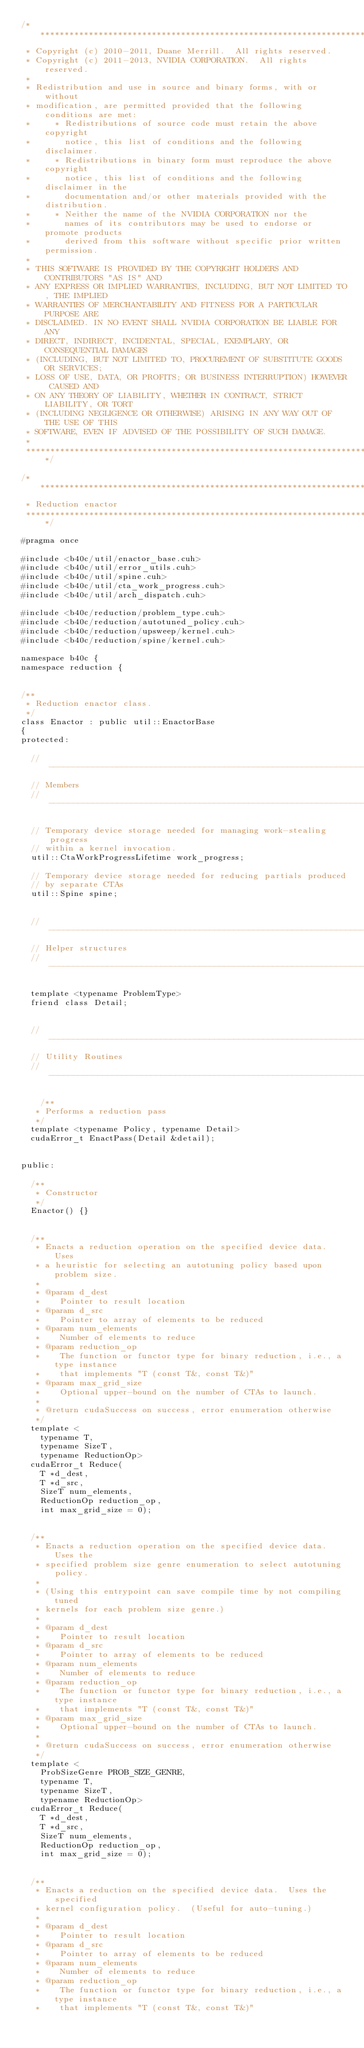Convert code to text. <code><loc_0><loc_0><loc_500><loc_500><_Cuda_>/******************************************************************************
 * Copyright (c) 2010-2011, Duane Merrill.  All rights reserved.
 * Copyright (c) 2011-2013, NVIDIA CORPORATION.  All rights reserved.
 * 
 * Redistribution and use in source and binary forms, with or without
 * modification, are permitted provided that the following conditions are met:
 *     * Redistributions of source code must retain the above copyright
 *       notice, this list of conditions and the following disclaimer.
 *     * Redistributions in binary form must reproduce the above copyright
 *       notice, this list of conditions and the following disclaimer in the
 *       documentation and/or other materials provided with the distribution.
 *     * Neither the name of the NVIDIA CORPORATION nor the
 *       names of its contributors may be used to endorse or promote products
 *       derived from this software without specific prior written permission.
 * 
 * THIS SOFTWARE IS PROVIDED BY THE COPYRIGHT HOLDERS AND CONTRIBUTORS "AS IS" AND
 * ANY EXPRESS OR IMPLIED WARRANTIES, INCLUDING, BUT NOT LIMITED TO, THE IMPLIED
 * WARRANTIES OF MERCHANTABILITY AND FITNESS FOR A PARTICULAR PURPOSE ARE
 * DISCLAIMED. IN NO EVENT SHALL NVIDIA CORPORATION BE LIABLE FOR ANY
 * DIRECT, INDIRECT, INCIDENTAL, SPECIAL, EXEMPLARY, OR CONSEQUENTIAL DAMAGES
 * (INCLUDING, BUT NOT LIMITED TO, PROCUREMENT OF SUBSTITUTE GOODS OR SERVICES;
 * LOSS OF USE, DATA, OR PROFITS; OR BUSINESS INTERRUPTION) HOWEVER CAUSED AND
 * ON ANY THEORY OF LIABILITY, WHETHER IN CONTRACT, STRICT LIABILITY, OR TORT
 * (INCLUDING NEGLIGENCE OR OTHERWISE) ARISING IN ANY WAY OUT OF THE USE OF THIS
 * SOFTWARE, EVEN IF ADVISED OF THE POSSIBILITY OF SUCH DAMAGE.
 *
 ******************************************************************************/

/******************************************************************************
 * Reduction enactor
 ******************************************************************************/

#pragma once

#include <b40c/util/enactor_base.cuh>
#include <b40c/util/error_utils.cuh>
#include <b40c/util/spine.cuh>
#include <b40c/util/cta_work_progress.cuh>
#include <b40c/util/arch_dispatch.cuh>

#include <b40c/reduction/problem_type.cuh>
#include <b40c/reduction/autotuned_policy.cuh>
#include <b40c/reduction/upsweep/kernel.cuh>
#include <b40c/reduction/spine/kernel.cuh>

namespace b40c {
namespace reduction {


/**
 * Reduction enactor class.
 */
class Enactor : public util::EnactorBase
{
protected:

	//---------------------------------------------------------------------
	// Members
	//---------------------------------------------------------------------

	// Temporary device storage needed for managing work-stealing progress
	// within a kernel invocation.
	util::CtaWorkProgressLifetime work_progress;

	// Temporary device storage needed for reducing partials produced
	// by separate CTAs
	util::Spine spine;


	//-----------------------------------------------------------------------------
	// Helper structures
	//-----------------------------------------------------------------------------

	template <typename ProblemType>
	friend class Detail;


	//-----------------------------------------------------------------------------
	// Utility Routines
	//-----------------------------------------------------------------------------

    /**
	 * Performs a reduction pass
	 */
	template <typename Policy, typename Detail>
	cudaError_t EnactPass(Detail &detail);


public:

	/**
	 * Constructor
	 */
	Enactor() {}


	/**
	 * Enacts a reduction operation on the specified device data.  Uses
	 * a heuristic for selecting an autotuning policy based upon problem size.
	 *
	 * @param d_dest
	 * 		Pointer to result location
	 * @param d_src
	 * 		Pointer to array of elements to be reduced
	 * @param num_elements
	 * 		Number of elements to reduce
	 * @param reduction_op
	 * 		The function or functor type for binary reduction, i.e., a type instance
	 * 		that implements "T (const T&, const T&)"
	 * @param max_grid_size
	 * 		Optional upper-bound on the number of CTAs to launch.
	 *
	 * @return cudaSuccess on success, error enumeration otherwise
	 */
	template <
		typename T,
		typename SizeT,
		typename ReductionOp>
	cudaError_t Reduce(
		T *d_dest,
		T *d_src,
		SizeT num_elements,
		ReductionOp reduction_op,
		int max_grid_size = 0);


	/**
	 * Enacts a reduction operation on the specified device data.  Uses the
	 * specified problem size genre enumeration to select autotuning policy.
	 *
	 * (Using this entrypoint can save compile time by not compiling tuned
	 * kernels for each problem size genre.)
	 *
	 * @param d_dest
	 * 		Pointer to result location
	 * @param d_src
	 * 		Pointer to array of elements to be reduced
	 * @param num_elements
	 * 		Number of elements to reduce
	 * @param reduction_op
	 * 		The function or functor type for binary reduction, i.e., a type instance
	 * 		that implements "T (const T&, const T&)"
	 * @param max_grid_size
	 * 		Optional upper-bound on the number of CTAs to launch.
	 *
	 * @return cudaSuccess on success, error enumeration otherwise
	 */
	template <
		ProbSizeGenre PROB_SIZE_GENRE,
		typename T,
		typename SizeT,
		typename ReductionOp>
	cudaError_t Reduce(
		T *d_dest,
		T *d_src,
		SizeT num_elements,
		ReductionOp reduction_op,
		int max_grid_size = 0);


	/**
	 * Enacts a reduction on the specified device data.  Uses the specified
	 * kernel configuration policy.  (Useful for auto-tuning.)
	 *
	 * @param d_dest
	 * 		Pointer to result location
	 * @param d_src
	 * 		Pointer to array of elements to be reduced
	 * @param num_elements
	 * 		Number of elements to reduce
	 * @param reduction_op
	 * 		The function or functor type for binary reduction, i.e., a type instance
	 * 		that implements "T (const T&, const T&)"</code> 